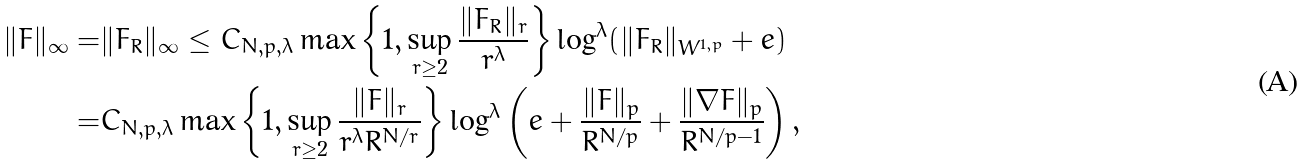Convert formula to latex. <formula><loc_0><loc_0><loc_500><loc_500>\| F \| _ { \infty } = & \| F _ { R } \| _ { \infty } \leq C _ { N , p , \lambda } \max \left \{ 1 , \sup _ { r \geq 2 } \frac { \| F _ { R } \| _ { r } } { r ^ { \lambda } } \right \} \log ^ { \lambda } ( \| F _ { R } \| _ { W ^ { 1 , p } } + e ) \\ = & C _ { N , p , \lambda } \max \left \{ 1 , \sup _ { r \geq 2 } \frac { \| F \| _ { r } } { r ^ { \lambda } R ^ { N / r } } \right \} \log ^ { \lambda } \left ( e + \frac { \| F \| _ { p } } { R ^ { N / p } } + \frac { \| \nabla F \| _ { p } } { R ^ { N / p - 1 } } \right ) ,</formula> 